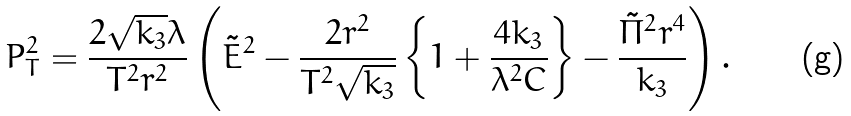<formula> <loc_0><loc_0><loc_500><loc_500>P _ { T } ^ { 2 } = \frac { 2 \sqrt { k _ { 3 } } \lambda } { T ^ { 2 } r ^ { 2 } } \left ( \tilde { E } ^ { 2 } - \frac { 2 r ^ { 2 } } { T ^ { 2 } \sqrt { k _ { 3 } } } \left \{ 1 + \frac { 4 k _ { 3 } } { \lambda ^ { 2 } C } \right \} - \frac { \tilde { \Pi } ^ { 2 } r ^ { 4 } } { k _ { 3 } } \right ) .</formula> 